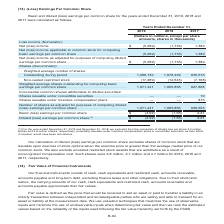According to Centurylink's financial document, For the Diluted (loss) earnings per common share, what was excluded for the years 2018 and 2019? we excluded from the calculation of diluted loss per share 3.0 million shares and 4.6 million shares, respectively, potentially issuable under incentive compensation plans or convertible securities, as their effect, if included, would have been anti-dilutive. The document states: "ar ended December 31, 2019 and December 31, 2018, we excluded from the calculation of diluted loss per share 3.0 million shares and 4.6 million shares..." Also, What was excluded as a result of unrecognized compensation cost? unvested restricted stock awards that are antidilutive. The document states: "market price of our common stock. We also exclude unvested restricted stock awards that are antidilutive as a result of unrecognized compensation cost..." Also, In which years were the unvested restricted stock awards that are antidilutive excluded? The document contains multiple relevant values: 2019, 2018, 2017. From the document: "2019 2018 2017 2019 2018 2017 2019 2018 2017..." Additionally, In which year was the Number of shares as adjusted for purposes of computing diluted (loss) earnings per common share  the largest? According to the financial document, 2019. The relevant text states: "2019 2018 2017..." Also, can you calculate: What is the total amount of unvested restricted stock awards that are antidilutive excluded in 2017, 2018 and 2019? Based on the calculation: 6.8+2.7+4.7, the result is 14.2 (in millions). This is based on the information: "compensation cost. Such shares were 6.8 million, 2.7 million and 4.7 million for 2019, 2018 and 2017, respectively. st. Such shares were 6.8 million, 2.7 million and 4.7 million for 2019, 2018 and 201..." The key data points involved are: 2.7, 4.7, 6.8. Also, can you calculate: What is the average annual amount of unvested restricted stock awards that are antidilutive excluded in 2017, 2018 and 2019? To answer this question, I need to perform calculations using the financial data. The calculation is: (6.8+2.7+4.7)/3, which equals 4.73 (in millions). This is based on the information: "compensation cost. Such shares were 6.8 million, 2.7 million and 4.7 million for 2019, 2018 and 2017, respectively. st. Such shares were 6.8 million, 2.7 million and 4.7 million for 2019, 2018 and 201..." The key data points involved are: 2.7, 6.8. 